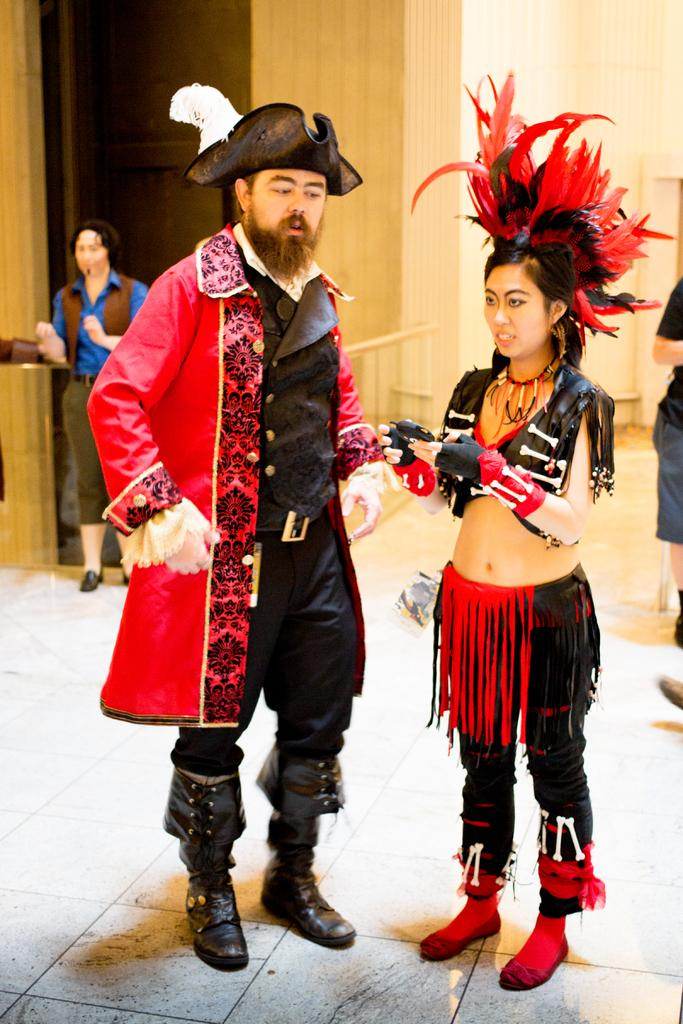How many people are present in the image? There are two people, a man and a woman, present in the image. What are the man and woman wearing? Both the man and woman are wearing costumes. What is the surface they are standing on? They are standing on the floor. What can be seen in the background of the image? There is a wall and two other persons in the background of the image. What type of pollution can be seen in the image? There is no pollution present in the image. What are the man and woman talking about in the image? The image does not show or provide information about what the man and woman might be talking about. 